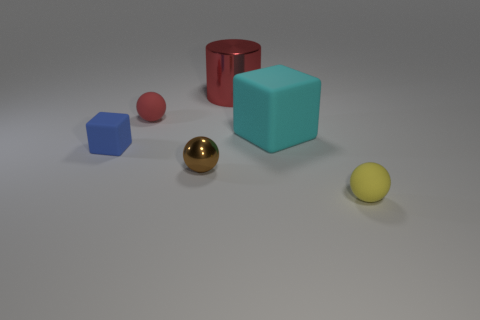Add 2 spheres. How many objects exist? 8 Subtract all tiny metal balls. How many balls are left? 2 Add 6 cylinders. How many cylinders are left? 7 Add 1 tiny red matte things. How many tiny red matte things exist? 2 Subtract all red balls. How many balls are left? 2 Subtract 0 green cylinders. How many objects are left? 6 Subtract all cubes. How many objects are left? 4 Subtract all gray cylinders. Subtract all blue cubes. How many cylinders are left? 1 Subtract all green spheres. How many green cylinders are left? 0 Subtract all small blue blocks. Subtract all cyan matte objects. How many objects are left? 4 